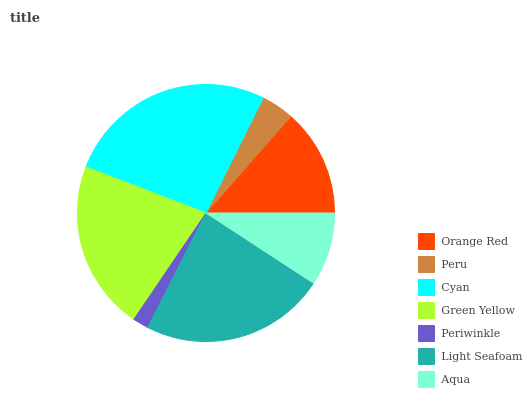Is Periwinkle the minimum?
Answer yes or no. Yes. Is Cyan the maximum?
Answer yes or no. Yes. Is Peru the minimum?
Answer yes or no. No. Is Peru the maximum?
Answer yes or no. No. Is Orange Red greater than Peru?
Answer yes or no. Yes. Is Peru less than Orange Red?
Answer yes or no. Yes. Is Peru greater than Orange Red?
Answer yes or no. No. Is Orange Red less than Peru?
Answer yes or no. No. Is Orange Red the high median?
Answer yes or no. Yes. Is Orange Red the low median?
Answer yes or no. Yes. Is Cyan the high median?
Answer yes or no. No. Is Aqua the low median?
Answer yes or no. No. 